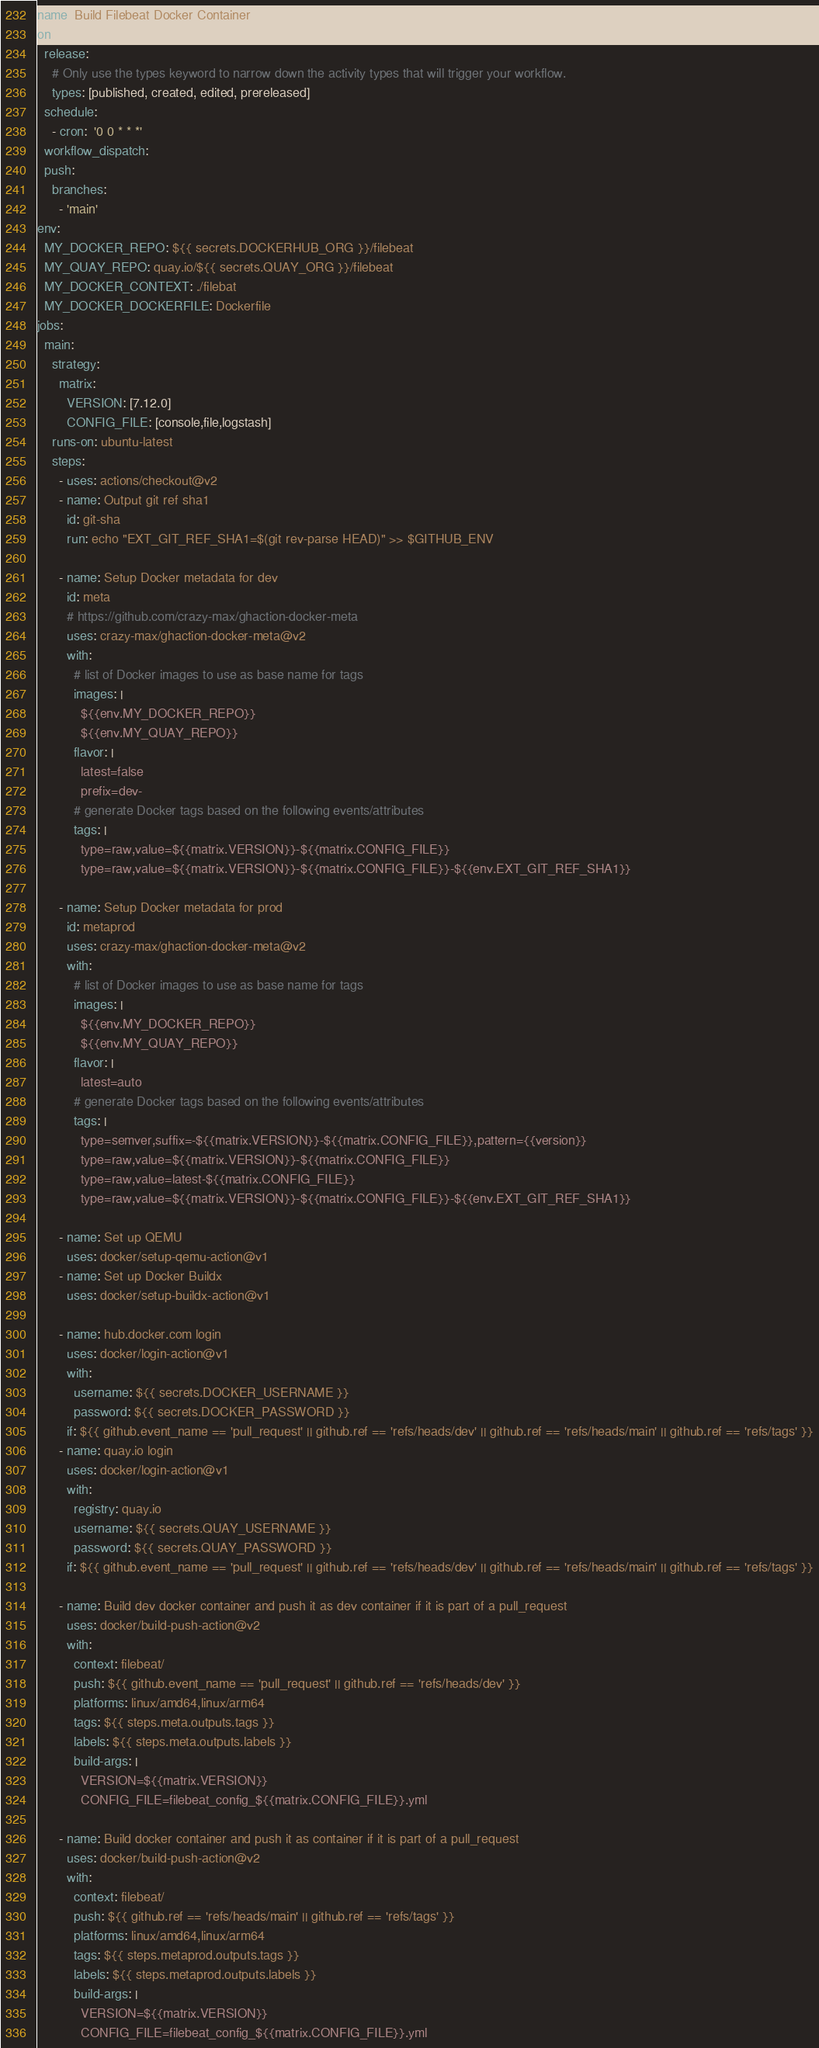<code> <loc_0><loc_0><loc_500><loc_500><_YAML_>name: Build Filebeat Docker Container
on: 
  release:
    # Only use the types keyword to narrow down the activity types that will trigger your workflow.
    types: [published, created, edited, prereleased]
  schedule:
    - cron:  '0 0 * * *'
  workflow_dispatch:
  push:
    branches:
      - 'main'
env:
  MY_DOCKER_REPO: ${{ secrets.DOCKERHUB_ORG }}/filebeat
  MY_QUAY_REPO: quay.io/${{ secrets.QUAY_ORG }}/filebeat
  MY_DOCKER_CONTEXT: ./filebat
  MY_DOCKER_DOCKERFILE: Dockerfile
jobs:
  main:
    strategy:
      matrix:
        VERSION: [7.12.0]
        CONFIG_FILE: [console,file,logstash]
    runs-on: ubuntu-latest
    steps:
      - uses: actions/checkout@v2
      - name: Output git ref sha1
        id: git-sha
        run: echo "EXT_GIT_REF_SHA1=$(git rev-parse HEAD)" >> $GITHUB_ENV

      - name: Setup Docker metadata for dev
        id: meta
        # https://github.com/crazy-max/ghaction-docker-meta
        uses: crazy-max/ghaction-docker-meta@v2
        with:
          # list of Docker images to use as base name for tags
          images: |
            ${{env.MY_DOCKER_REPO}}
            ${{env.MY_QUAY_REPO}}
          flavor: |
            latest=false
            prefix=dev-
          # generate Docker tags based on the following events/attributes
          tags: |
            type=raw,value=${{matrix.VERSION}}-${{matrix.CONFIG_FILE}}
            type=raw,value=${{matrix.VERSION}}-${{matrix.CONFIG_FILE}}-${{env.EXT_GIT_REF_SHA1}}

      - name: Setup Docker metadata for prod
        id: metaprod
        uses: crazy-max/ghaction-docker-meta@v2
        with:
          # list of Docker images to use as base name for tags
          images: |
            ${{env.MY_DOCKER_REPO}}
            ${{env.MY_QUAY_REPO}}
          flavor: |
            latest=auto
          # generate Docker tags based on the following events/attributes
          tags: |
            type=semver,suffix=-${{matrix.VERSION}}-${{matrix.CONFIG_FILE}},pattern={{version}}
            type=raw,value=${{matrix.VERSION}}-${{matrix.CONFIG_FILE}}
            type=raw,value=latest-${{matrix.CONFIG_FILE}}
            type=raw,value=${{matrix.VERSION}}-${{matrix.CONFIG_FILE}}-${{env.EXT_GIT_REF_SHA1}}

      - name: Set up QEMU
        uses: docker/setup-qemu-action@v1
      - name: Set up Docker Buildx
        uses: docker/setup-buildx-action@v1

      - name: hub.docker.com login
        uses: docker/login-action@v1
        with:
          username: ${{ secrets.DOCKER_USERNAME }}
          password: ${{ secrets.DOCKER_PASSWORD }}
        if: ${{ github.event_name == 'pull_request' || github.ref == 'refs/heads/dev' || github.ref == 'refs/heads/main' || github.ref == 'refs/tags' }}
      - name: quay.io login
        uses: docker/login-action@v1
        with:
          registry: quay.io
          username: ${{ secrets.QUAY_USERNAME }}
          password: ${{ secrets.QUAY_PASSWORD }}
        if: ${{ github.event_name == 'pull_request' || github.ref == 'refs/heads/dev' || github.ref == 'refs/heads/main' || github.ref == 'refs/tags' }}

      - name: Build dev docker container and push it as dev container if it is part of a pull_request
        uses: docker/build-push-action@v2
        with:
          context: filebeat/
          push: ${{ github.event_name == 'pull_request' || github.ref == 'refs/heads/dev' }}
          platforms: linux/amd64,linux/arm64
          tags: ${{ steps.meta.outputs.tags }}
          labels: ${{ steps.meta.outputs.labels }}
          build-args: |
            VERSION=${{matrix.VERSION}}
            CONFIG_FILE=filebeat_config_${{matrix.CONFIG_FILE}}.yml
      
      - name: Build docker container and push it as container if it is part of a pull_request
        uses: docker/build-push-action@v2
        with:
          context: filebeat/
          push: ${{ github.ref == 'refs/heads/main' || github.ref == 'refs/tags' }}
          platforms: linux/amd64,linux/arm64
          tags: ${{ steps.metaprod.outputs.tags }}
          labels: ${{ steps.metaprod.outputs.labels }}
          build-args: |
            VERSION=${{matrix.VERSION}}
            CONFIG_FILE=filebeat_config_${{matrix.CONFIG_FILE}}.yml</code> 